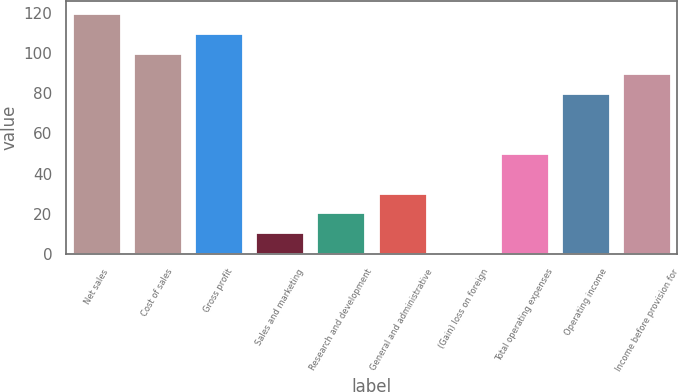Convert chart. <chart><loc_0><loc_0><loc_500><loc_500><bar_chart><fcel>Net sales<fcel>Cost of sales<fcel>Gross profit<fcel>Sales and marketing<fcel>Research and development<fcel>General and administrative<fcel>(Gain) loss on foreign<fcel>Total operating expenses<fcel>Operating income<fcel>Income before provision for<nl><fcel>119.82<fcel>100<fcel>109.91<fcel>10.81<fcel>20.72<fcel>30.63<fcel>0.9<fcel>50.45<fcel>80.18<fcel>90.09<nl></chart> 